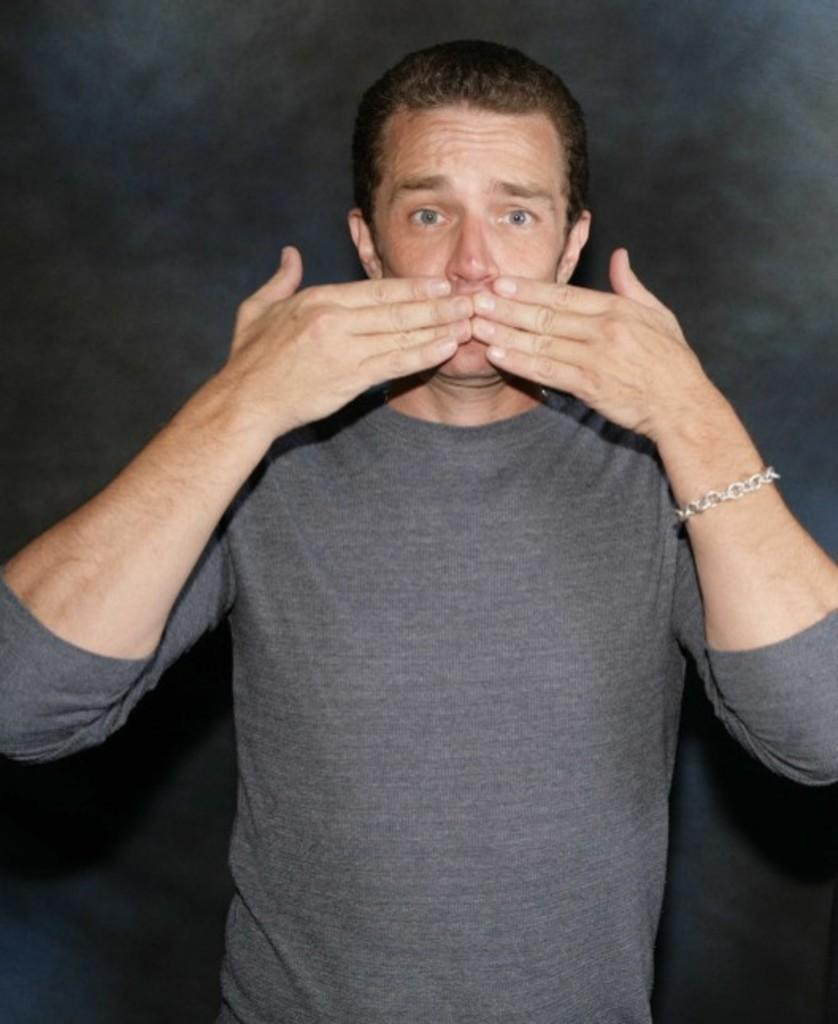What is the main subject of the image? There is a person standing in the center of the image. What can be observed about the background of the image? The background of the image is dark. What type of coach is present in the image? There is no coach present in the image; it features a person standing in the center with a dark background. What is the size of the dust particles visible in the image? There is no dust visible in the image, as it only features a person standing in the center with a dark background. 